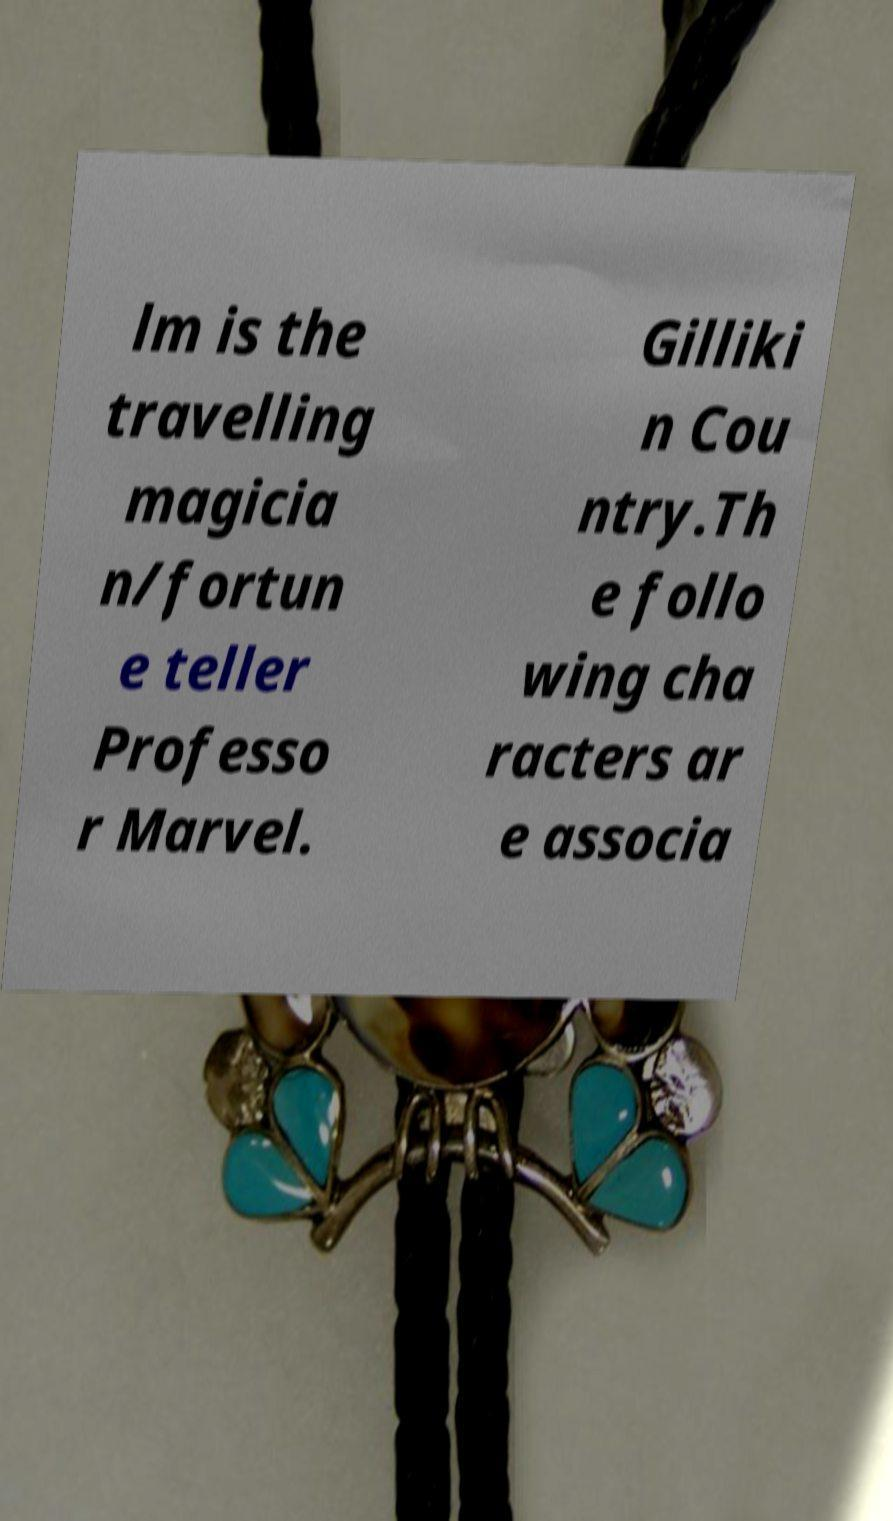Please identify and transcribe the text found in this image. lm is the travelling magicia n/fortun e teller Professo r Marvel. Gilliki n Cou ntry.Th e follo wing cha racters ar e associa 